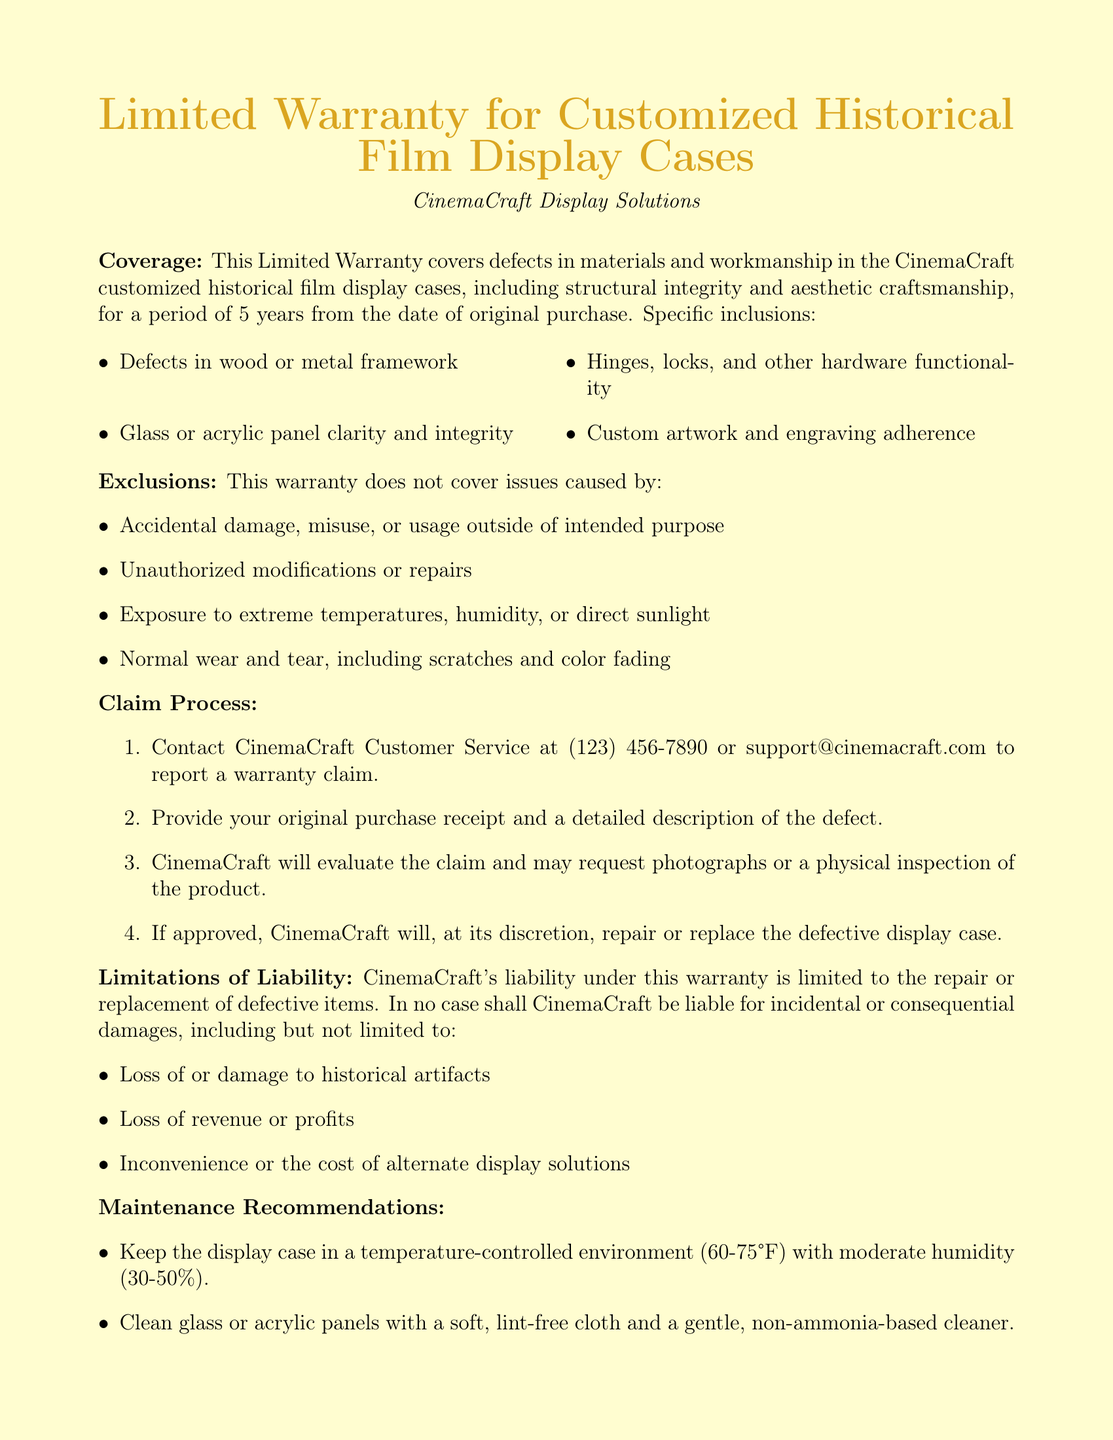what is the warranty period for the display cases? The warranty period for the display cases is specified as 5 years from the date of original purchase.
Answer: 5 years what is excluded from the warranty coverage? The document lists specific exclusions from the warranty coverage, including accidental damage and normal wear and tear.
Answer: Accidental damage, misuse, or usage outside of intended purpose how can a customer initiate a warranty claim? The claim process begins with contacting CinemaCraft Customer Service at the provided contact information.
Answer: Contact CinemaCraft Customer Service who should be contacted for warranty claims? The document provides a specific contact for warranty claims, which is CinemaCraft Customer Service, along with a phone number.
Answer: CinemaCraft Customer Service what type of damages are not covered under the warranty? The warranty explicitly states that incidental or consequential damages such as loss of historical artifacts are not covered.
Answer: Loss of or damage to historical artifacts what materials are guaranteed under the warranty? The warranty guarantees defects in specific materials such as wood and metal framework.
Answer: Wood or metal framework how does CinemaCraft handle approved warranty claims? Upon approval of a warranty claim, CinemaCraft decides whether to repair or replace the defective display case.
Answer: Repair or replace the defective display case what is the maintenance recommendation regarding temperature? The document recommends keeping the display case in a temperature-controlled environment between certain temperatures.
Answer: 60-75°F 